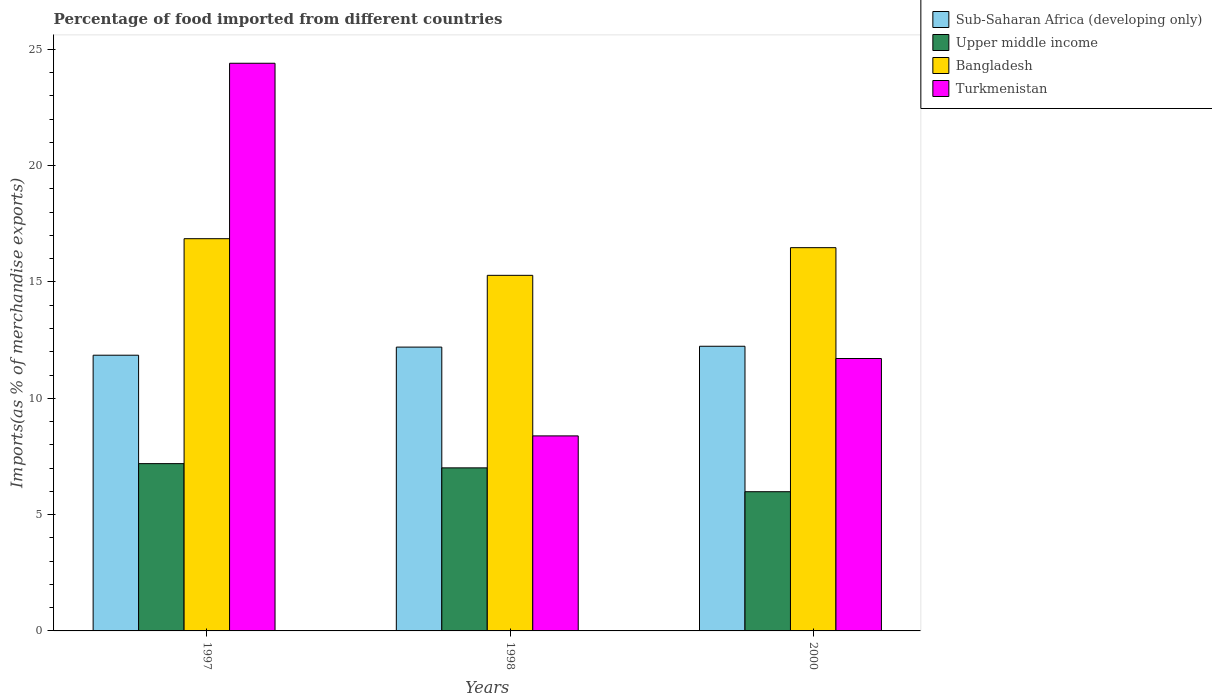How many different coloured bars are there?
Keep it short and to the point. 4. How many groups of bars are there?
Make the answer very short. 3. How many bars are there on the 1st tick from the left?
Provide a succinct answer. 4. How many bars are there on the 2nd tick from the right?
Offer a very short reply. 4. What is the percentage of imports to different countries in Bangladesh in 1997?
Give a very brief answer. 16.86. Across all years, what is the maximum percentage of imports to different countries in Sub-Saharan Africa (developing only)?
Ensure brevity in your answer.  12.24. Across all years, what is the minimum percentage of imports to different countries in Upper middle income?
Provide a short and direct response. 5.98. In which year was the percentage of imports to different countries in Turkmenistan maximum?
Offer a very short reply. 1997. In which year was the percentage of imports to different countries in Turkmenistan minimum?
Offer a very short reply. 1998. What is the total percentage of imports to different countries in Turkmenistan in the graph?
Keep it short and to the point. 44.5. What is the difference between the percentage of imports to different countries in Upper middle income in 1997 and that in 2000?
Your answer should be very brief. 1.21. What is the difference between the percentage of imports to different countries in Sub-Saharan Africa (developing only) in 2000 and the percentage of imports to different countries in Bangladesh in 1997?
Offer a terse response. -4.62. What is the average percentage of imports to different countries in Sub-Saharan Africa (developing only) per year?
Your answer should be compact. 12.1. In the year 1997, what is the difference between the percentage of imports to different countries in Sub-Saharan Africa (developing only) and percentage of imports to different countries in Upper middle income?
Your response must be concise. 4.66. In how many years, is the percentage of imports to different countries in Turkmenistan greater than 12 %?
Keep it short and to the point. 1. What is the ratio of the percentage of imports to different countries in Upper middle income in 1997 to that in 1998?
Make the answer very short. 1.03. What is the difference between the highest and the second highest percentage of imports to different countries in Sub-Saharan Africa (developing only)?
Offer a terse response. 0.04. What is the difference between the highest and the lowest percentage of imports to different countries in Upper middle income?
Offer a terse response. 1.21. Is the sum of the percentage of imports to different countries in Sub-Saharan Africa (developing only) in 1997 and 1998 greater than the maximum percentage of imports to different countries in Upper middle income across all years?
Your answer should be very brief. Yes. What does the 4th bar from the left in 1997 represents?
Ensure brevity in your answer.  Turkmenistan. What does the 4th bar from the right in 1998 represents?
Offer a terse response. Sub-Saharan Africa (developing only). Is it the case that in every year, the sum of the percentage of imports to different countries in Sub-Saharan Africa (developing only) and percentage of imports to different countries in Upper middle income is greater than the percentage of imports to different countries in Turkmenistan?
Your response must be concise. No. How many bars are there?
Your answer should be compact. 12. How many years are there in the graph?
Your response must be concise. 3. Does the graph contain grids?
Your answer should be compact. No. Where does the legend appear in the graph?
Your response must be concise. Top right. How many legend labels are there?
Keep it short and to the point. 4. How are the legend labels stacked?
Your response must be concise. Vertical. What is the title of the graph?
Offer a terse response. Percentage of food imported from different countries. Does "Euro area" appear as one of the legend labels in the graph?
Provide a succinct answer. No. What is the label or title of the Y-axis?
Make the answer very short. Imports(as % of merchandise exports). What is the Imports(as % of merchandise exports) in Sub-Saharan Africa (developing only) in 1997?
Offer a very short reply. 11.85. What is the Imports(as % of merchandise exports) in Upper middle income in 1997?
Your response must be concise. 7.19. What is the Imports(as % of merchandise exports) in Bangladesh in 1997?
Your answer should be very brief. 16.86. What is the Imports(as % of merchandise exports) in Turkmenistan in 1997?
Keep it short and to the point. 24.4. What is the Imports(as % of merchandise exports) of Sub-Saharan Africa (developing only) in 1998?
Keep it short and to the point. 12.2. What is the Imports(as % of merchandise exports) in Upper middle income in 1998?
Provide a succinct answer. 7.01. What is the Imports(as % of merchandise exports) of Bangladesh in 1998?
Provide a succinct answer. 15.29. What is the Imports(as % of merchandise exports) of Turkmenistan in 1998?
Offer a very short reply. 8.38. What is the Imports(as % of merchandise exports) of Sub-Saharan Africa (developing only) in 2000?
Ensure brevity in your answer.  12.24. What is the Imports(as % of merchandise exports) in Upper middle income in 2000?
Offer a very short reply. 5.98. What is the Imports(as % of merchandise exports) in Bangladesh in 2000?
Give a very brief answer. 16.48. What is the Imports(as % of merchandise exports) in Turkmenistan in 2000?
Make the answer very short. 11.71. Across all years, what is the maximum Imports(as % of merchandise exports) in Sub-Saharan Africa (developing only)?
Your answer should be very brief. 12.24. Across all years, what is the maximum Imports(as % of merchandise exports) of Upper middle income?
Give a very brief answer. 7.19. Across all years, what is the maximum Imports(as % of merchandise exports) in Bangladesh?
Your answer should be compact. 16.86. Across all years, what is the maximum Imports(as % of merchandise exports) of Turkmenistan?
Provide a succinct answer. 24.4. Across all years, what is the minimum Imports(as % of merchandise exports) of Sub-Saharan Africa (developing only)?
Provide a short and direct response. 11.85. Across all years, what is the minimum Imports(as % of merchandise exports) in Upper middle income?
Your answer should be very brief. 5.98. Across all years, what is the minimum Imports(as % of merchandise exports) in Bangladesh?
Provide a succinct answer. 15.29. Across all years, what is the minimum Imports(as % of merchandise exports) in Turkmenistan?
Provide a succinct answer. 8.38. What is the total Imports(as % of merchandise exports) of Sub-Saharan Africa (developing only) in the graph?
Your response must be concise. 36.29. What is the total Imports(as % of merchandise exports) of Upper middle income in the graph?
Offer a terse response. 20.19. What is the total Imports(as % of merchandise exports) in Bangladesh in the graph?
Provide a succinct answer. 48.62. What is the total Imports(as % of merchandise exports) of Turkmenistan in the graph?
Your response must be concise. 44.5. What is the difference between the Imports(as % of merchandise exports) of Sub-Saharan Africa (developing only) in 1997 and that in 1998?
Make the answer very short. -0.35. What is the difference between the Imports(as % of merchandise exports) in Upper middle income in 1997 and that in 1998?
Your answer should be compact. 0.18. What is the difference between the Imports(as % of merchandise exports) of Bangladesh in 1997 and that in 1998?
Your answer should be very brief. 1.58. What is the difference between the Imports(as % of merchandise exports) of Turkmenistan in 1997 and that in 1998?
Your response must be concise. 16.02. What is the difference between the Imports(as % of merchandise exports) of Sub-Saharan Africa (developing only) in 1997 and that in 2000?
Your response must be concise. -0.38. What is the difference between the Imports(as % of merchandise exports) in Upper middle income in 1997 and that in 2000?
Your response must be concise. 1.21. What is the difference between the Imports(as % of merchandise exports) in Bangladesh in 1997 and that in 2000?
Provide a short and direct response. 0.39. What is the difference between the Imports(as % of merchandise exports) in Turkmenistan in 1997 and that in 2000?
Your answer should be compact. 12.69. What is the difference between the Imports(as % of merchandise exports) of Sub-Saharan Africa (developing only) in 1998 and that in 2000?
Provide a short and direct response. -0.04. What is the difference between the Imports(as % of merchandise exports) of Upper middle income in 1998 and that in 2000?
Keep it short and to the point. 1.02. What is the difference between the Imports(as % of merchandise exports) in Bangladesh in 1998 and that in 2000?
Give a very brief answer. -1.19. What is the difference between the Imports(as % of merchandise exports) in Turkmenistan in 1998 and that in 2000?
Offer a very short reply. -3.33. What is the difference between the Imports(as % of merchandise exports) in Sub-Saharan Africa (developing only) in 1997 and the Imports(as % of merchandise exports) in Upper middle income in 1998?
Your response must be concise. 4.84. What is the difference between the Imports(as % of merchandise exports) of Sub-Saharan Africa (developing only) in 1997 and the Imports(as % of merchandise exports) of Bangladesh in 1998?
Give a very brief answer. -3.43. What is the difference between the Imports(as % of merchandise exports) of Sub-Saharan Africa (developing only) in 1997 and the Imports(as % of merchandise exports) of Turkmenistan in 1998?
Ensure brevity in your answer.  3.47. What is the difference between the Imports(as % of merchandise exports) in Upper middle income in 1997 and the Imports(as % of merchandise exports) in Bangladesh in 1998?
Your answer should be very brief. -8.09. What is the difference between the Imports(as % of merchandise exports) of Upper middle income in 1997 and the Imports(as % of merchandise exports) of Turkmenistan in 1998?
Give a very brief answer. -1.19. What is the difference between the Imports(as % of merchandise exports) in Bangladesh in 1997 and the Imports(as % of merchandise exports) in Turkmenistan in 1998?
Offer a terse response. 8.48. What is the difference between the Imports(as % of merchandise exports) in Sub-Saharan Africa (developing only) in 1997 and the Imports(as % of merchandise exports) in Upper middle income in 2000?
Offer a very short reply. 5.87. What is the difference between the Imports(as % of merchandise exports) of Sub-Saharan Africa (developing only) in 1997 and the Imports(as % of merchandise exports) of Bangladesh in 2000?
Give a very brief answer. -4.62. What is the difference between the Imports(as % of merchandise exports) in Sub-Saharan Africa (developing only) in 1997 and the Imports(as % of merchandise exports) in Turkmenistan in 2000?
Your answer should be very brief. 0.14. What is the difference between the Imports(as % of merchandise exports) of Upper middle income in 1997 and the Imports(as % of merchandise exports) of Bangladesh in 2000?
Keep it short and to the point. -9.28. What is the difference between the Imports(as % of merchandise exports) in Upper middle income in 1997 and the Imports(as % of merchandise exports) in Turkmenistan in 2000?
Offer a terse response. -4.52. What is the difference between the Imports(as % of merchandise exports) in Bangladesh in 1997 and the Imports(as % of merchandise exports) in Turkmenistan in 2000?
Make the answer very short. 5.15. What is the difference between the Imports(as % of merchandise exports) in Sub-Saharan Africa (developing only) in 1998 and the Imports(as % of merchandise exports) in Upper middle income in 2000?
Your response must be concise. 6.22. What is the difference between the Imports(as % of merchandise exports) in Sub-Saharan Africa (developing only) in 1998 and the Imports(as % of merchandise exports) in Bangladesh in 2000?
Keep it short and to the point. -4.27. What is the difference between the Imports(as % of merchandise exports) of Sub-Saharan Africa (developing only) in 1998 and the Imports(as % of merchandise exports) of Turkmenistan in 2000?
Ensure brevity in your answer.  0.49. What is the difference between the Imports(as % of merchandise exports) in Upper middle income in 1998 and the Imports(as % of merchandise exports) in Bangladesh in 2000?
Your answer should be very brief. -9.47. What is the difference between the Imports(as % of merchandise exports) in Upper middle income in 1998 and the Imports(as % of merchandise exports) in Turkmenistan in 2000?
Ensure brevity in your answer.  -4.7. What is the difference between the Imports(as % of merchandise exports) of Bangladesh in 1998 and the Imports(as % of merchandise exports) of Turkmenistan in 2000?
Give a very brief answer. 3.58. What is the average Imports(as % of merchandise exports) of Sub-Saharan Africa (developing only) per year?
Provide a succinct answer. 12.1. What is the average Imports(as % of merchandise exports) of Upper middle income per year?
Offer a very short reply. 6.73. What is the average Imports(as % of merchandise exports) in Bangladesh per year?
Provide a succinct answer. 16.21. What is the average Imports(as % of merchandise exports) of Turkmenistan per year?
Give a very brief answer. 14.83. In the year 1997, what is the difference between the Imports(as % of merchandise exports) in Sub-Saharan Africa (developing only) and Imports(as % of merchandise exports) in Upper middle income?
Offer a terse response. 4.66. In the year 1997, what is the difference between the Imports(as % of merchandise exports) in Sub-Saharan Africa (developing only) and Imports(as % of merchandise exports) in Bangladesh?
Ensure brevity in your answer.  -5.01. In the year 1997, what is the difference between the Imports(as % of merchandise exports) in Sub-Saharan Africa (developing only) and Imports(as % of merchandise exports) in Turkmenistan?
Your response must be concise. -12.55. In the year 1997, what is the difference between the Imports(as % of merchandise exports) in Upper middle income and Imports(as % of merchandise exports) in Bangladesh?
Provide a succinct answer. -9.67. In the year 1997, what is the difference between the Imports(as % of merchandise exports) in Upper middle income and Imports(as % of merchandise exports) in Turkmenistan?
Ensure brevity in your answer.  -17.21. In the year 1997, what is the difference between the Imports(as % of merchandise exports) in Bangladesh and Imports(as % of merchandise exports) in Turkmenistan?
Keep it short and to the point. -7.54. In the year 1998, what is the difference between the Imports(as % of merchandise exports) in Sub-Saharan Africa (developing only) and Imports(as % of merchandise exports) in Upper middle income?
Your response must be concise. 5.19. In the year 1998, what is the difference between the Imports(as % of merchandise exports) in Sub-Saharan Africa (developing only) and Imports(as % of merchandise exports) in Bangladesh?
Offer a terse response. -3.08. In the year 1998, what is the difference between the Imports(as % of merchandise exports) in Sub-Saharan Africa (developing only) and Imports(as % of merchandise exports) in Turkmenistan?
Your answer should be very brief. 3.82. In the year 1998, what is the difference between the Imports(as % of merchandise exports) in Upper middle income and Imports(as % of merchandise exports) in Bangladesh?
Ensure brevity in your answer.  -8.28. In the year 1998, what is the difference between the Imports(as % of merchandise exports) of Upper middle income and Imports(as % of merchandise exports) of Turkmenistan?
Give a very brief answer. -1.37. In the year 1998, what is the difference between the Imports(as % of merchandise exports) in Bangladesh and Imports(as % of merchandise exports) in Turkmenistan?
Give a very brief answer. 6.9. In the year 2000, what is the difference between the Imports(as % of merchandise exports) of Sub-Saharan Africa (developing only) and Imports(as % of merchandise exports) of Upper middle income?
Offer a very short reply. 6.25. In the year 2000, what is the difference between the Imports(as % of merchandise exports) of Sub-Saharan Africa (developing only) and Imports(as % of merchandise exports) of Bangladesh?
Keep it short and to the point. -4.24. In the year 2000, what is the difference between the Imports(as % of merchandise exports) in Sub-Saharan Africa (developing only) and Imports(as % of merchandise exports) in Turkmenistan?
Your answer should be very brief. 0.53. In the year 2000, what is the difference between the Imports(as % of merchandise exports) of Upper middle income and Imports(as % of merchandise exports) of Bangladesh?
Your response must be concise. -10.49. In the year 2000, what is the difference between the Imports(as % of merchandise exports) in Upper middle income and Imports(as % of merchandise exports) in Turkmenistan?
Provide a short and direct response. -5.73. In the year 2000, what is the difference between the Imports(as % of merchandise exports) in Bangladesh and Imports(as % of merchandise exports) in Turkmenistan?
Give a very brief answer. 4.77. What is the ratio of the Imports(as % of merchandise exports) in Sub-Saharan Africa (developing only) in 1997 to that in 1998?
Your response must be concise. 0.97. What is the ratio of the Imports(as % of merchandise exports) in Upper middle income in 1997 to that in 1998?
Your response must be concise. 1.03. What is the ratio of the Imports(as % of merchandise exports) in Bangladesh in 1997 to that in 1998?
Your answer should be very brief. 1.1. What is the ratio of the Imports(as % of merchandise exports) in Turkmenistan in 1997 to that in 1998?
Your answer should be very brief. 2.91. What is the ratio of the Imports(as % of merchandise exports) of Sub-Saharan Africa (developing only) in 1997 to that in 2000?
Your answer should be compact. 0.97. What is the ratio of the Imports(as % of merchandise exports) in Upper middle income in 1997 to that in 2000?
Give a very brief answer. 1.2. What is the ratio of the Imports(as % of merchandise exports) of Bangladesh in 1997 to that in 2000?
Provide a short and direct response. 1.02. What is the ratio of the Imports(as % of merchandise exports) in Turkmenistan in 1997 to that in 2000?
Your answer should be compact. 2.08. What is the ratio of the Imports(as % of merchandise exports) in Sub-Saharan Africa (developing only) in 1998 to that in 2000?
Offer a terse response. 1. What is the ratio of the Imports(as % of merchandise exports) of Upper middle income in 1998 to that in 2000?
Provide a succinct answer. 1.17. What is the ratio of the Imports(as % of merchandise exports) of Bangladesh in 1998 to that in 2000?
Make the answer very short. 0.93. What is the ratio of the Imports(as % of merchandise exports) in Turkmenistan in 1998 to that in 2000?
Ensure brevity in your answer.  0.72. What is the difference between the highest and the second highest Imports(as % of merchandise exports) of Sub-Saharan Africa (developing only)?
Provide a succinct answer. 0.04. What is the difference between the highest and the second highest Imports(as % of merchandise exports) of Upper middle income?
Keep it short and to the point. 0.18. What is the difference between the highest and the second highest Imports(as % of merchandise exports) in Bangladesh?
Provide a short and direct response. 0.39. What is the difference between the highest and the second highest Imports(as % of merchandise exports) of Turkmenistan?
Your answer should be very brief. 12.69. What is the difference between the highest and the lowest Imports(as % of merchandise exports) of Sub-Saharan Africa (developing only)?
Ensure brevity in your answer.  0.38. What is the difference between the highest and the lowest Imports(as % of merchandise exports) in Upper middle income?
Give a very brief answer. 1.21. What is the difference between the highest and the lowest Imports(as % of merchandise exports) of Bangladesh?
Provide a short and direct response. 1.58. What is the difference between the highest and the lowest Imports(as % of merchandise exports) in Turkmenistan?
Give a very brief answer. 16.02. 